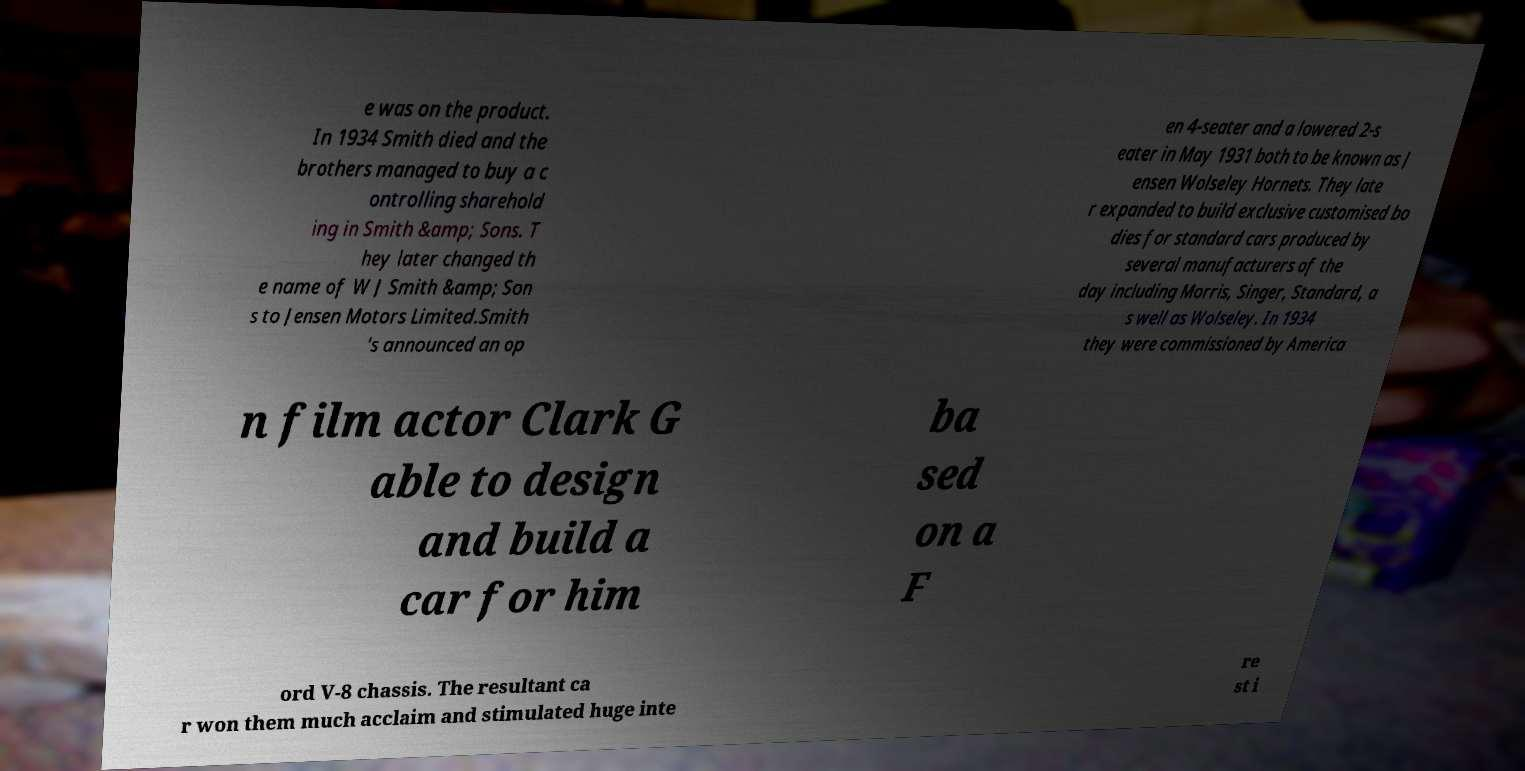Can you accurately transcribe the text from the provided image for me? e was on the product. In 1934 Smith died and the brothers managed to buy a c ontrolling sharehold ing in Smith &amp; Sons. T hey later changed th e name of W J Smith &amp; Son s to Jensen Motors Limited.Smith 's announced an op en 4-seater and a lowered 2-s eater in May 1931 both to be known as J ensen Wolseley Hornets. They late r expanded to build exclusive customised bo dies for standard cars produced by several manufacturers of the day including Morris, Singer, Standard, a s well as Wolseley. In 1934 they were commissioned by America n film actor Clark G able to design and build a car for him ba sed on a F ord V-8 chassis. The resultant ca r won them much acclaim and stimulated huge inte re st i 